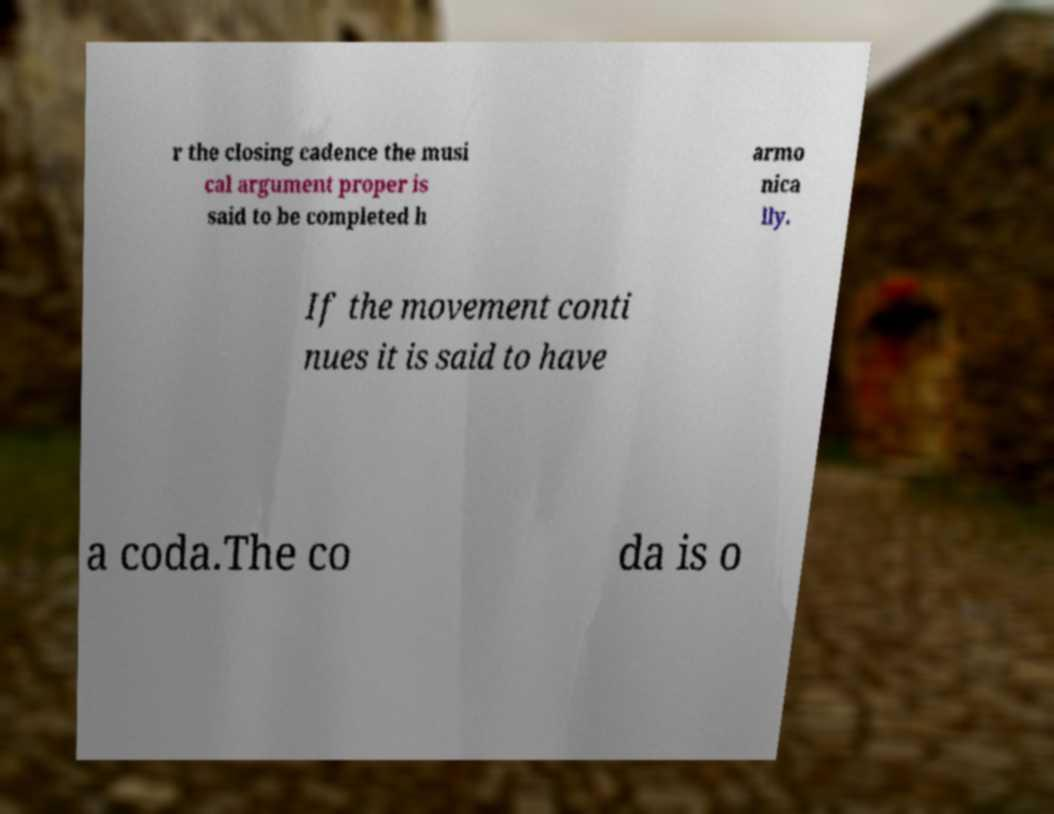For documentation purposes, I need the text within this image transcribed. Could you provide that? r the closing cadence the musi cal argument proper is said to be completed h armo nica lly. If the movement conti nues it is said to have a coda.The co da is o 